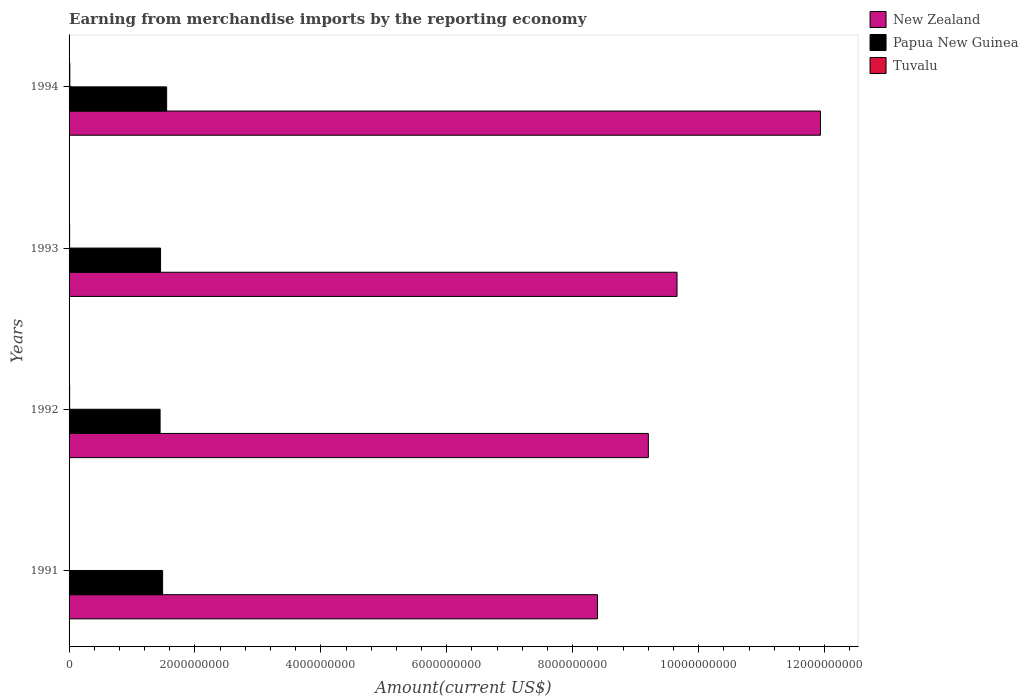Are the number of bars on each tick of the Y-axis equal?
Your response must be concise. Yes. How many bars are there on the 4th tick from the top?
Provide a succinct answer. 3. What is the amount earned from merchandise imports in New Zealand in 1994?
Your answer should be compact. 1.19e+1. Across all years, what is the maximum amount earned from merchandise imports in Tuvalu?
Offer a very short reply. 1.18e+07. Across all years, what is the minimum amount earned from merchandise imports in New Zealand?
Your answer should be very brief. 8.39e+09. What is the total amount earned from merchandise imports in Tuvalu in the graph?
Your answer should be compact. 3.20e+07. What is the difference between the amount earned from merchandise imports in Papua New Guinea in 1992 and that in 1993?
Provide a short and direct response. -7.38e+06. What is the difference between the amount earned from merchandise imports in Papua New Guinea in 1992 and the amount earned from merchandise imports in Tuvalu in 1991?
Provide a succinct answer. 1.44e+09. What is the average amount earned from merchandise imports in Papua New Guinea per year?
Ensure brevity in your answer.  1.48e+09. In the year 1993, what is the difference between the amount earned from merchandise imports in Tuvalu and amount earned from merchandise imports in New Zealand?
Provide a short and direct response. -9.65e+09. In how many years, is the amount earned from merchandise imports in Tuvalu greater than 9600000000 US$?
Offer a very short reply. 0. What is the ratio of the amount earned from merchandise imports in New Zealand in 1991 to that in 1993?
Give a very brief answer. 0.87. Is the difference between the amount earned from merchandise imports in Tuvalu in 1992 and 1993 greater than the difference between the amount earned from merchandise imports in New Zealand in 1992 and 1993?
Your answer should be compact. Yes. What is the difference between the highest and the second highest amount earned from merchandise imports in Tuvalu?
Make the answer very short. 2.58e+06. What is the difference between the highest and the lowest amount earned from merchandise imports in New Zealand?
Your answer should be very brief. 3.54e+09. Is the sum of the amount earned from merchandise imports in Papua New Guinea in 1991 and 1993 greater than the maximum amount earned from merchandise imports in Tuvalu across all years?
Your answer should be compact. Yes. What does the 2nd bar from the top in 1992 represents?
Your response must be concise. Papua New Guinea. What does the 3rd bar from the bottom in 1991 represents?
Provide a short and direct response. Tuvalu. How many bars are there?
Your response must be concise. 12. How many years are there in the graph?
Your response must be concise. 4. Does the graph contain any zero values?
Ensure brevity in your answer.  No. Does the graph contain grids?
Provide a short and direct response. No. How are the legend labels stacked?
Offer a very short reply. Vertical. What is the title of the graph?
Make the answer very short. Earning from merchandise imports by the reporting economy. Does "Macedonia" appear as one of the legend labels in the graph?
Ensure brevity in your answer.  No. What is the label or title of the X-axis?
Ensure brevity in your answer.  Amount(current US$). What is the Amount(current US$) in New Zealand in 1991?
Make the answer very short. 8.39e+09. What is the Amount(current US$) of Papua New Guinea in 1991?
Give a very brief answer. 1.49e+09. What is the Amount(current US$) in Tuvalu in 1991?
Make the answer very short. 2.28e+06. What is the Amount(current US$) in New Zealand in 1992?
Make the answer very short. 9.20e+09. What is the Amount(current US$) of Papua New Guinea in 1992?
Make the answer very short. 1.45e+09. What is the Amount(current US$) in Tuvalu in 1992?
Ensure brevity in your answer.  9.18e+06. What is the Amount(current US$) in New Zealand in 1993?
Provide a short and direct response. 9.66e+09. What is the Amount(current US$) in Papua New Guinea in 1993?
Offer a very short reply. 1.45e+09. What is the Amount(current US$) in Tuvalu in 1993?
Give a very brief answer. 8.77e+06. What is the Amount(current US$) of New Zealand in 1994?
Your answer should be very brief. 1.19e+1. What is the Amount(current US$) of Papua New Guinea in 1994?
Keep it short and to the point. 1.55e+09. What is the Amount(current US$) in Tuvalu in 1994?
Give a very brief answer. 1.18e+07. Across all years, what is the maximum Amount(current US$) in New Zealand?
Your answer should be very brief. 1.19e+1. Across all years, what is the maximum Amount(current US$) of Papua New Guinea?
Make the answer very short. 1.55e+09. Across all years, what is the maximum Amount(current US$) in Tuvalu?
Ensure brevity in your answer.  1.18e+07. Across all years, what is the minimum Amount(current US$) in New Zealand?
Provide a short and direct response. 8.39e+09. Across all years, what is the minimum Amount(current US$) in Papua New Guinea?
Make the answer very short. 1.45e+09. Across all years, what is the minimum Amount(current US$) of Tuvalu?
Your response must be concise. 2.28e+06. What is the total Amount(current US$) in New Zealand in the graph?
Give a very brief answer. 3.92e+1. What is the total Amount(current US$) in Papua New Guinea in the graph?
Offer a terse response. 5.93e+09. What is the total Amount(current US$) of Tuvalu in the graph?
Make the answer very short. 3.20e+07. What is the difference between the Amount(current US$) in New Zealand in 1991 and that in 1992?
Provide a succinct answer. -8.08e+08. What is the difference between the Amount(current US$) of Papua New Guinea in 1991 and that in 1992?
Provide a short and direct response. 4.02e+07. What is the difference between the Amount(current US$) in Tuvalu in 1991 and that in 1992?
Your answer should be very brief. -6.90e+06. What is the difference between the Amount(current US$) of New Zealand in 1991 and that in 1993?
Your response must be concise. -1.26e+09. What is the difference between the Amount(current US$) of Papua New Guinea in 1991 and that in 1993?
Keep it short and to the point. 3.28e+07. What is the difference between the Amount(current US$) in Tuvalu in 1991 and that in 1993?
Provide a succinct answer. -6.49e+06. What is the difference between the Amount(current US$) in New Zealand in 1991 and that in 1994?
Provide a short and direct response. -3.54e+09. What is the difference between the Amount(current US$) of Papua New Guinea in 1991 and that in 1994?
Keep it short and to the point. -6.40e+07. What is the difference between the Amount(current US$) in Tuvalu in 1991 and that in 1994?
Keep it short and to the point. -9.48e+06. What is the difference between the Amount(current US$) of New Zealand in 1992 and that in 1993?
Offer a very short reply. -4.56e+08. What is the difference between the Amount(current US$) in Papua New Guinea in 1992 and that in 1993?
Offer a terse response. -7.38e+06. What is the difference between the Amount(current US$) of Tuvalu in 1992 and that in 1993?
Offer a terse response. 4.12e+05. What is the difference between the Amount(current US$) of New Zealand in 1992 and that in 1994?
Provide a short and direct response. -2.73e+09. What is the difference between the Amount(current US$) of Papua New Guinea in 1992 and that in 1994?
Give a very brief answer. -1.04e+08. What is the difference between the Amount(current US$) of Tuvalu in 1992 and that in 1994?
Provide a succinct answer. -2.58e+06. What is the difference between the Amount(current US$) of New Zealand in 1993 and that in 1994?
Make the answer very short. -2.28e+09. What is the difference between the Amount(current US$) of Papua New Guinea in 1993 and that in 1994?
Make the answer very short. -9.68e+07. What is the difference between the Amount(current US$) of Tuvalu in 1993 and that in 1994?
Offer a very short reply. -2.99e+06. What is the difference between the Amount(current US$) of New Zealand in 1991 and the Amount(current US$) of Papua New Guinea in 1992?
Make the answer very short. 6.95e+09. What is the difference between the Amount(current US$) in New Zealand in 1991 and the Amount(current US$) in Tuvalu in 1992?
Provide a short and direct response. 8.38e+09. What is the difference between the Amount(current US$) in Papua New Guinea in 1991 and the Amount(current US$) in Tuvalu in 1992?
Provide a succinct answer. 1.48e+09. What is the difference between the Amount(current US$) in New Zealand in 1991 and the Amount(current US$) in Papua New Guinea in 1993?
Ensure brevity in your answer.  6.94e+09. What is the difference between the Amount(current US$) of New Zealand in 1991 and the Amount(current US$) of Tuvalu in 1993?
Offer a very short reply. 8.38e+09. What is the difference between the Amount(current US$) in Papua New Guinea in 1991 and the Amount(current US$) in Tuvalu in 1993?
Your answer should be very brief. 1.48e+09. What is the difference between the Amount(current US$) in New Zealand in 1991 and the Amount(current US$) in Papua New Guinea in 1994?
Offer a terse response. 6.84e+09. What is the difference between the Amount(current US$) in New Zealand in 1991 and the Amount(current US$) in Tuvalu in 1994?
Your answer should be very brief. 8.38e+09. What is the difference between the Amount(current US$) in Papua New Guinea in 1991 and the Amount(current US$) in Tuvalu in 1994?
Your answer should be very brief. 1.47e+09. What is the difference between the Amount(current US$) of New Zealand in 1992 and the Amount(current US$) of Papua New Guinea in 1993?
Give a very brief answer. 7.75e+09. What is the difference between the Amount(current US$) in New Zealand in 1992 and the Amount(current US$) in Tuvalu in 1993?
Give a very brief answer. 9.19e+09. What is the difference between the Amount(current US$) of Papua New Guinea in 1992 and the Amount(current US$) of Tuvalu in 1993?
Give a very brief answer. 1.44e+09. What is the difference between the Amount(current US$) of New Zealand in 1992 and the Amount(current US$) of Papua New Guinea in 1994?
Offer a very short reply. 7.65e+09. What is the difference between the Amount(current US$) of New Zealand in 1992 and the Amount(current US$) of Tuvalu in 1994?
Ensure brevity in your answer.  9.19e+09. What is the difference between the Amount(current US$) in Papua New Guinea in 1992 and the Amount(current US$) in Tuvalu in 1994?
Your answer should be very brief. 1.43e+09. What is the difference between the Amount(current US$) in New Zealand in 1993 and the Amount(current US$) in Papua New Guinea in 1994?
Offer a very short reply. 8.11e+09. What is the difference between the Amount(current US$) of New Zealand in 1993 and the Amount(current US$) of Tuvalu in 1994?
Provide a succinct answer. 9.65e+09. What is the difference between the Amount(current US$) of Papua New Guinea in 1993 and the Amount(current US$) of Tuvalu in 1994?
Provide a short and direct response. 1.44e+09. What is the average Amount(current US$) of New Zealand per year?
Provide a succinct answer. 9.80e+09. What is the average Amount(current US$) in Papua New Guinea per year?
Your answer should be very brief. 1.48e+09. What is the average Amount(current US$) of Tuvalu per year?
Provide a short and direct response. 7.99e+06. In the year 1991, what is the difference between the Amount(current US$) in New Zealand and Amount(current US$) in Papua New Guinea?
Make the answer very short. 6.91e+09. In the year 1991, what is the difference between the Amount(current US$) of New Zealand and Amount(current US$) of Tuvalu?
Provide a short and direct response. 8.39e+09. In the year 1991, what is the difference between the Amount(current US$) of Papua New Guinea and Amount(current US$) of Tuvalu?
Provide a succinct answer. 1.48e+09. In the year 1992, what is the difference between the Amount(current US$) in New Zealand and Amount(current US$) in Papua New Guinea?
Offer a very short reply. 7.76e+09. In the year 1992, what is the difference between the Amount(current US$) in New Zealand and Amount(current US$) in Tuvalu?
Offer a terse response. 9.19e+09. In the year 1992, what is the difference between the Amount(current US$) in Papua New Guinea and Amount(current US$) in Tuvalu?
Your answer should be very brief. 1.44e+09. In the year 1993, what is the difference between the Amount(current US$) in New Zealand and Amount(current US$) in Papua New Guinea?
Your answer should be very brief. 8.20e+09. In the year 1993, what is the difference between the Amount(current US$) in New Zealand and Amount(current US$) in Tuvalu?
Your answer should be very brief. 9.65e+09. In the year 1993, what is the difference between the Amount(current US$) of Papua New Guinea and Amount(current US$) of Tuvalu?
Provide a short and direct response. 1.44e+09. In the year 1994, what is the difference between the Amount(current US$) of New Zealand and Amount(current US$) of Papua New Guinea?
Give a very brief answer. 1.04e+1. In the year 1994, what is the difference between the Amount(current US$) in New Zealand and Amount(current US$) in Tuvalu?
Provide a succinct answer. 1.19e+1. In the year 1994, what is the difference between the Amount(current US$) of Papua New Guinea and Amount(current US$) of Tuvalu?
Provide a short and direct response. 1.54e+09. What is the ratio of the Amount(current US$) in New Zealand in 1991 to that in 1992?
Your response must be concise. 0.91. What is the ratio of the Amount(current US$) of Papua New Guinea in 1991 to that in 1992?
Your response must be concise. 1.03. What is the ratio of the Amount(current US$) of Tuvalu in 1991 to that in 1992?
Provide a short and direct response. 0.25. What is the ratio of the Amount(current US$) in New Zealand in 1991 to that in 1993?
Keep it short and to the point. 0.87. What is the ratio of the Amount(current US$) in Papua New Guinea in 1991 to that in 1993?
Make the answer very short. 1.02. What is the ratio of the Amount(current US$) of Tuvalu in 1991 to that in 1993?
Offer a terse response. 0.26. What is the ratio of the Amount(current US$) of New Zealand in 1991 to that in 1994?
Ensure brevity in your answer.  0.7. What is the ratio of the Amount(current US$) in Papua New Guinea in 1991 to that in 1994?
Ensure brevity in your answer.  0.96. What is the ratio of the Amount(current US$) in Tuvalu in 1991 to that in 1994?
Your answer should be very brief. 0.19. What is the ratio of the Amount(current US$) of New Zealand in 1992 to that in 1993?
Offer a very short reply. 0.95. What is the ratio of the Amount(current US$) in Tuvalu in 1992 to that in 1993?
Your answer should be very brief. 1.05. What is the ratio of the Amount(current US$) of New Zealand in 1992 to that in 1994?
Your answer should be compact. 0.77. What is the ratio of the Amount(current US$) of Papua New Guinea in 1992 to that in 1994?
Your answer should be compact. 0.93. What is the ratio of the Amount(current US$) of Tuvalu in 1992 to that in 1994?
Your answer should be very brief. 0.78. What is the ratio of the Amount(current US$) in New Zealand in 1993 to that in 1994?
Keep it short and to the point. 0.81. What is the ratio of the Amount(current US$) of Papua New Guinea in 1993 to that in 1994?
Offer a very short reply. 0.94. What is the ratio of the Amount(current US$) of Tuvalu in 1993 to that in 1994?
Give a very brief answer. 0.75. What is the difference between the highest and the second highest Amount(current US$) of New Zealand?
Make the answer very short. 2.28e+09. What is the difference between the highest and the second highest Amount(current US$) of Papua New Guinea?
Your response must be concise. 6.40e+07. What is the difference between the highest and the second highest Amount(current US$) in Tuvalu?
Offer a very short reply. 2.58e+06. What is the difference between the highest and the lowest Amount(current US$) in New Zealand?
Make the answer very short. 3.54e+09. What is the difference between the highest and the lowest Amount(current US$) of Papua New Guinea?
Your answer should be compact. 1.04e+08. What is the difference between the highest and the lowest Amount(current US$) of Tuvalu?
Your response must be concise. 9.48e+06. 